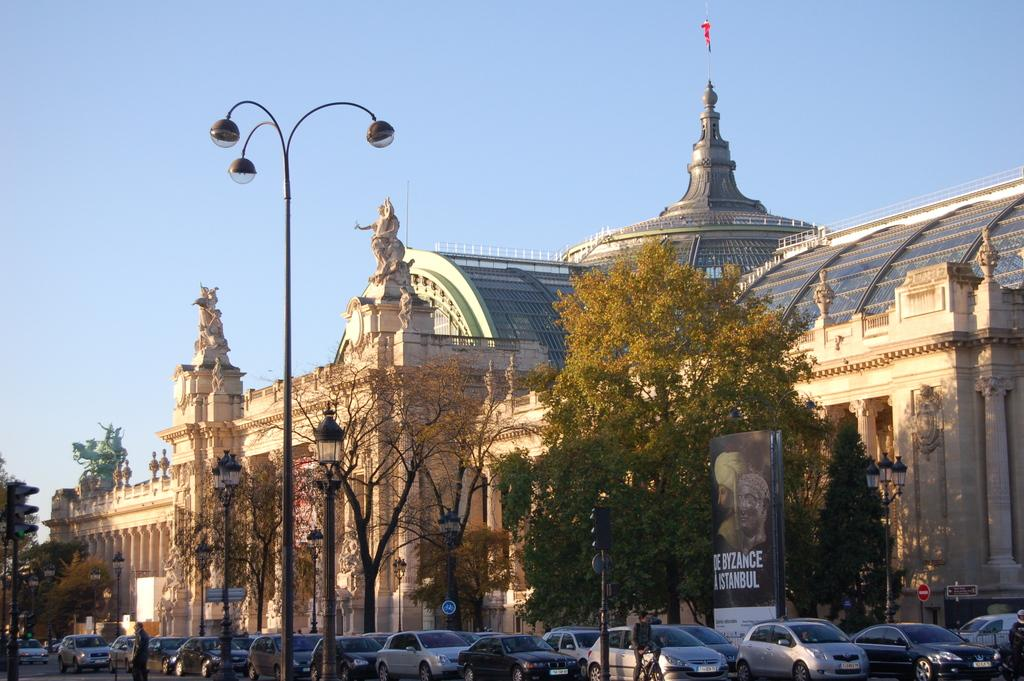What can be seen on the road in the image? There are vehicles on the road in the image. What objects are present in the image besides the vehicles? There are poles, lights, trees, boards, hoarding, buildings, and people in the image. What is the background of the image? The sky is visible in the background of the image. What type of curtain is hanging in the image? There is no curtain present in the image. What agreement was reached between the people in the image? There is no indication of any agreement being reached in the image. 